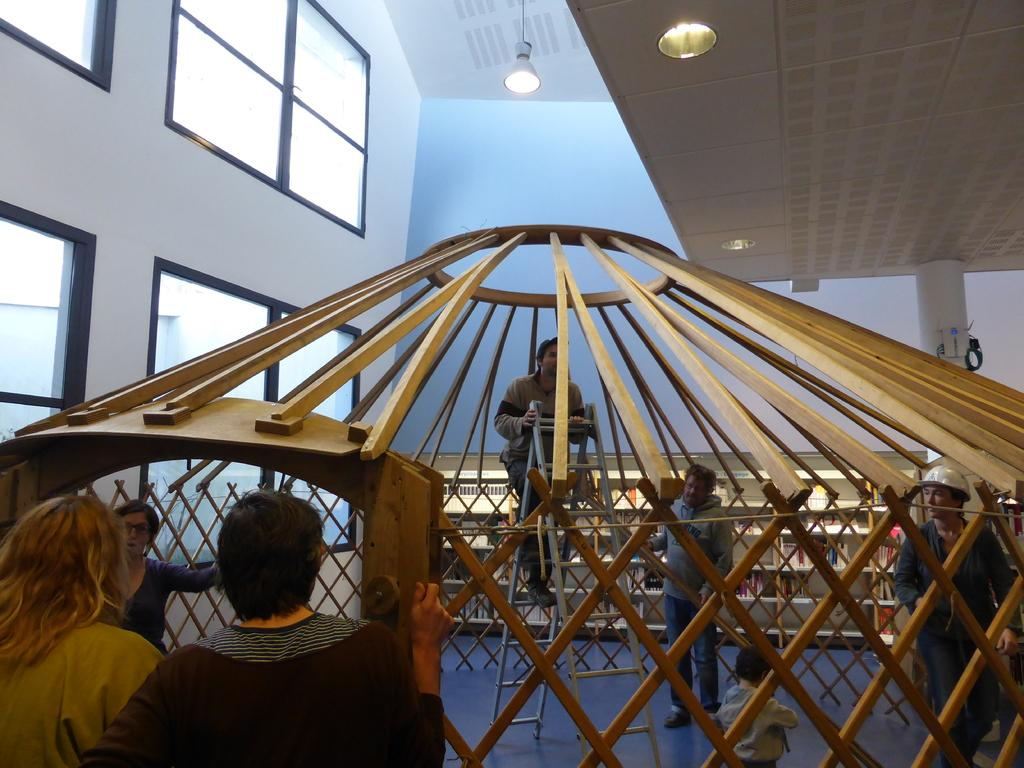How many people are in the image? There are few persons in the image. What type of structure can be seen in the image? It appears to be a wooden cage in the image. Where are the windows located in the image? There are windows on the left side of the image. What type of lighting is present in the image? There are lights hanging from the ceiling at the top of the image. Is the donkey mentioned in the image? No, there is no mention of a donkey in the image. Is the sleet visible in the image? No, there is no mention of sleet in the image. 